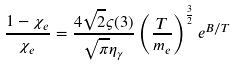<formula> <loc_0><loc_0><loc_500><loc_500>\frac { { 1 - \chi _ { e } } } { { \chi _ { e } } } = \frac { { 4 \sqrt { 2 } \varsigma ( 3 ) } } { { \sqrt { \pi } \eta _ { \gamma } } } \left ( { \frac { T } { { m _ { e } } } } \right ) ^ { \frac { 3 } { 2 } } e ^ { B / T }</formula> 